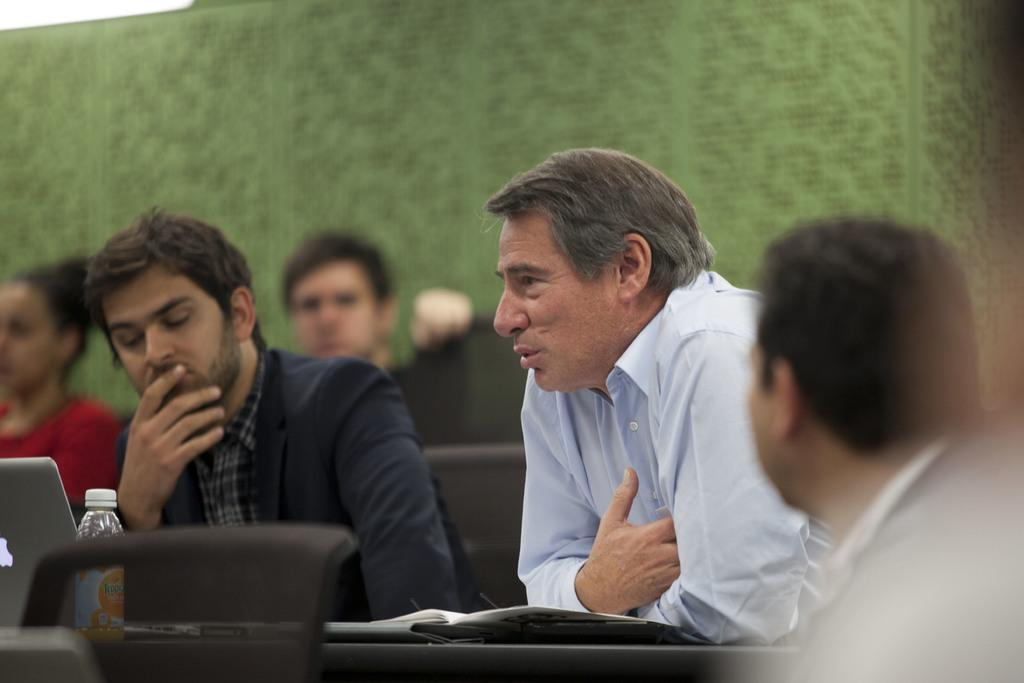What are the people in the image doing? The people in the image are sitting on chairs in the center of the image. What can be seen in the background of the image? There is a green color carpet in the background of the image. What type of rifle is being offered to the people in the image? There is no rifle present in the image; the people are simply sitting on chairs. 